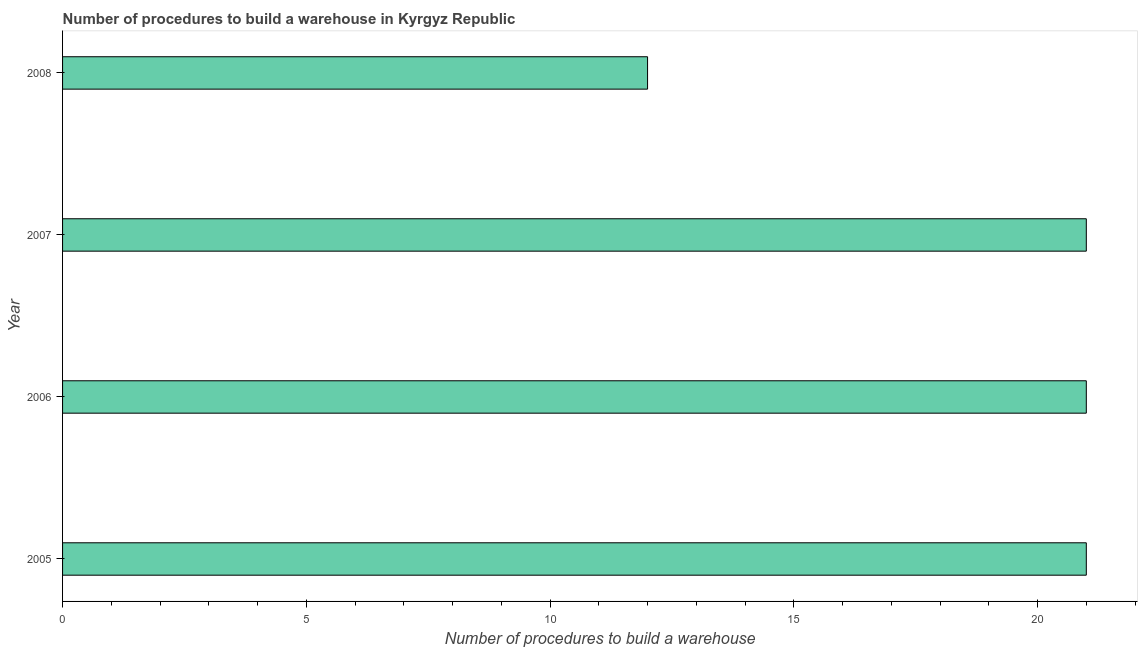Does the graph contain grids?
Provide a short and direct response. No. What is the title of the graph?
Your answer should be compact. Number of procedures to build a warehouse in Kyrgyz Republic. What is the label or title of the X-axis?
Keep it short and to the point. Number of procedures to build a warehouse. What is the label or title of the Y-axis?
Give a very brief answer. Year. In which year was the number of procedures to build a warehouse maximum?
Ensure brevity in your answer.  2005. In which year was the number of procedures to build a warehouse minimum?
Provide a succinct answer. 2008. What is the median number of procedures to build a warehouse?
Your answer should be very brief. 21. Do a majority of the years between 2008 and 2007 (inclusive) have number of procedures to build a warehouse greater than 16 ?
Provide a short and direct response. No. What is the ratio of the number of procedures to build a warehouse in 2005 to that in 2007?
Your answer should be compact. 1. Is the difference between the number of procedures to build a warehouse in 2005 and 2008 greater than the difference between any two years?
Keep it short and to the point. Yes. What is the difference between the highest and the second highest number of procedures to build a warehouse?
Offer a terse response. 0. Is the sum of the number of procedures to build a warehouse in 2006 and 2007 greater than the maximum number of procedures to build a warehouse across all years?
Provide a succinct answer. Yes. How many years are there in the graph?
Offer a terse response. 4. What is the difference between two consecutive major ticks on the X-axis?
Offer a terse response. 5. Are the values on the major ticks of X-axis written in scientific E-notation?
Your answer should be very brief. No. What is the Number of procedures to build a warehouse in 2005?
Give a very brief answer. 21. What is the Number of procedures to build a warehouse of 2007?
Ensure brevity in your answer.  21. What is the difference between the Number of procedures to build a warehouse in 2005 and 2006?
Your answer should be very brief. 0. What is the difference between the Number of procedures to build a warehouse in 2006 and 2007?
Offer a terse response. 0. What is the difference between the Number of procedures to build a warehouse in 2006 and 2008?
Offer a terse response. 9. What is the ratio of the Number of procedures to build a warehouse in 2005 to that in 2007?
Provide a short and direct response. 1. What is the ratio of the Number of procedures to build a warehouse in 2005 to that in 2008?
Provide a succinct answer. 1.75. What is the ratio of the Number of procedures to build a warehouse in 2006 to that in 2008?
Keep it short and to the point. 1.75. 